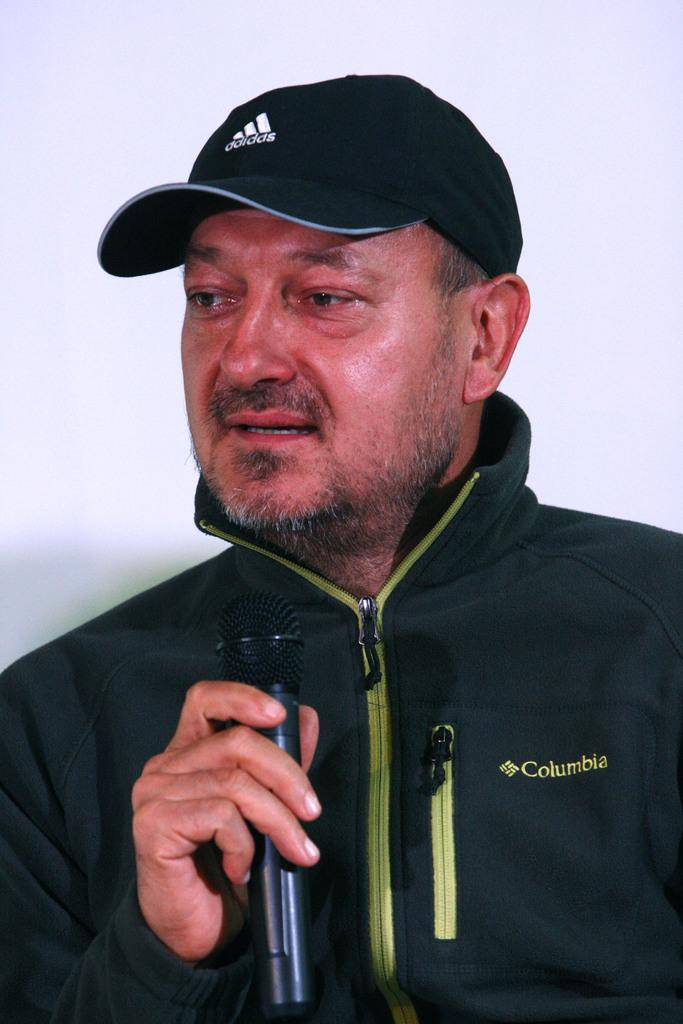What is the main subject of the picture? The main subject of the picture is a man. What is the man holding in his hand? The man is holding a microphone in his hand. What type of clothing is the man wearing? The man is wearing a jacket and a black color cap. What is the color of the background in the image? The background of the image is white in color. Can you see a cart filled with plastic items in the image? There is no cart or plastic items present in the image. Is the man wearing a winter coat in the image? The man is wearing a jacket, but there is no indication that it is a winter coat. 